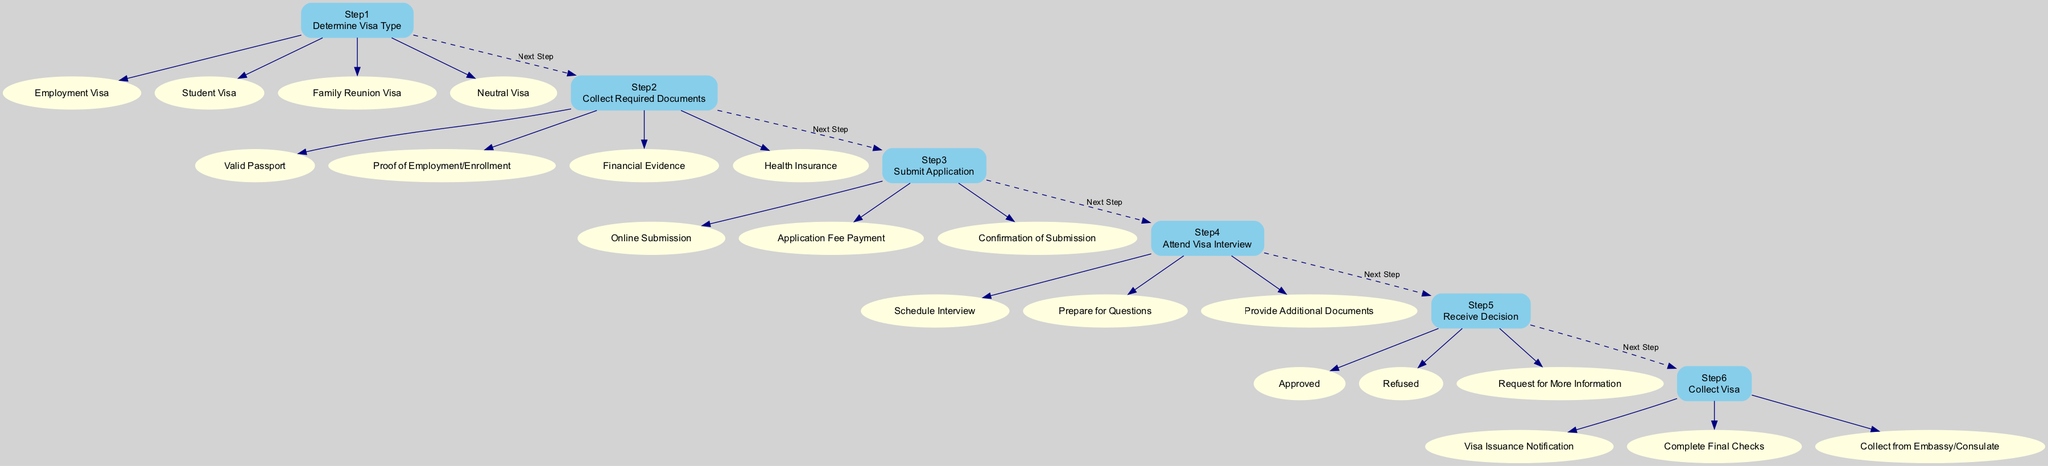What is the first step in the visa application process? The diagram indicates that the first step is "Step1: Determine Visa Type." This is the starting point for the visa application process, where the applicant needs to identify the type of visa they require.
Answer: Determine Visa Type How many criteria are there for Step3? In Step3, there are three criteria listed: "Online Submission," "Application Fee Payment," and "Confirmation of Submission." Counting these criteria reveals that there are three.
Answer: 3 What is the last step of the visa application process? According to the diagram, the final step is "Step6: Collect Visa." This indicates that after receiving the decision, the applicant moves to collect their visa.
Answer: Collect Visa List one criterion under Step2. The criteria under Step2 include "Valid Passport," "Proof of Employment/Enrollment," "Financial Evidence," and "Health Insurance." Any one of these can be listed as a valid answer.
Answer: Valid Passport What is the outcome options available in Step5? In Step5, the possible outcomes listed are "Approved," "Refused," and "Request for More Information." This indicates the decision that can be made regarding the visa application.
Answer: Approved, Refused, Request for More Information If the application is approved, what is the next step? If the application is approved in Step5, the next step according to the diagram is "Step6: Collect Visa." This indicates the final action the applicant must take if their application is successful.
Answer: Collect Visa What type of visa is listed under Step1 criteria? Under Step1, there are several types listed for visa consideration: "Employment Visa," "Student Visa," "Family Reunion Visa," and "Neutral Visa." This indicates the different categories available for applicants.
Answer: Employment Visa How many total steps are in the visa application process? The diagram outlines a total of six steps in the visa application process, numbered from Step1 to Step6. This indicates the complexity and structure of the process.
Answer: 6 